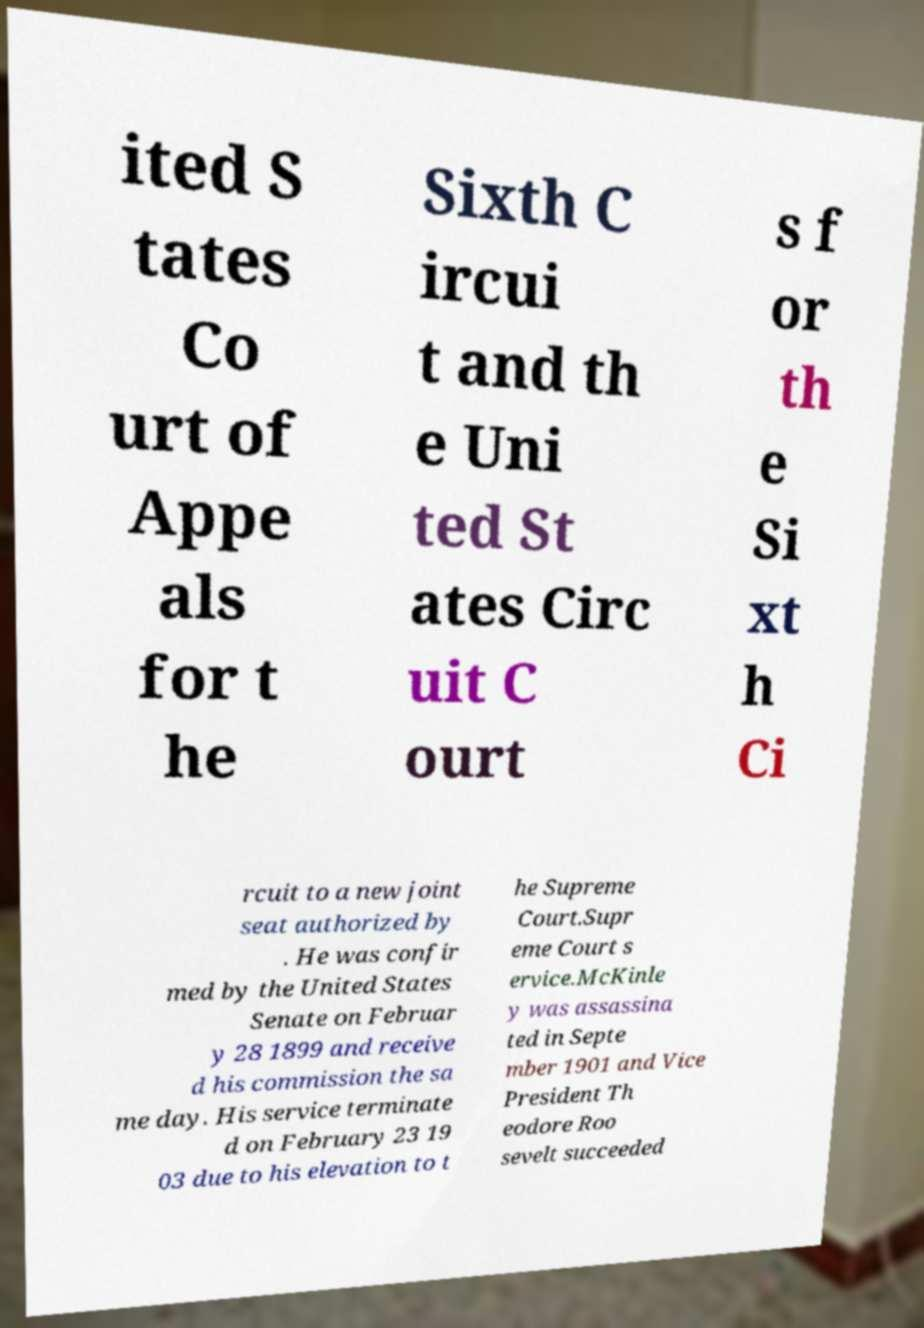Could you assist in decoding the text presented in this image and type it out clearly? ited S tates Co urt of Appe als for t he Sixth C ircui t and th e Uni ted St ates Circ uit C ourt s f or th e Si xt h Ci rcuit to a new joint seat authorized by . He was confir med by the United States Senate on Februar y 28 1899 and receive d his commission the sa me day. His service terminate d on February 23 19 03 due to his elevation to t he Supreme Court.Supr eme Court s ervice.McKinle y was assassina ted in Septe mber 1901 and Vice President Th eodore Roo sevelt succeeded 